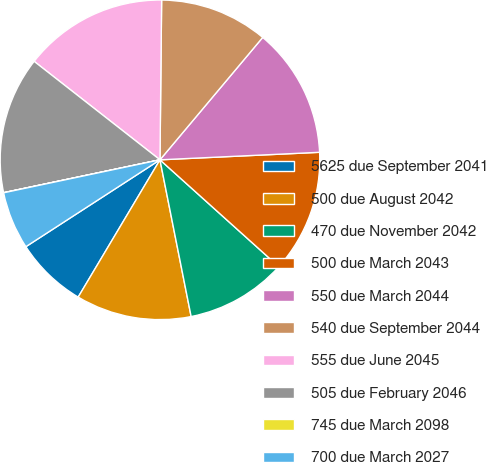Convert chart to OTSL. <chart><loc_0><loc_0><loc_500><loc_500><pie_chart><fcel>5625 due September 2041<fcel>500 due August 2042<fcel>470 due November 2042<fcel>500 due March 2043<fcel>550 due March 2044<fcel>540 due September 2044<fcel>555 due June 2045<fcel>505 due February 2046<fcel>745 due March 2098<fcel>700 due March 2027<nl><fcel>7.3%<fcel>11.68%<fcel>10.22%<fcel>12.41%<fcel>13.14%<fcel>10.95%<fcel>14.6%<fcel>13.87%<fcel>0.01%<fcel>5.84%<nl></chart> 